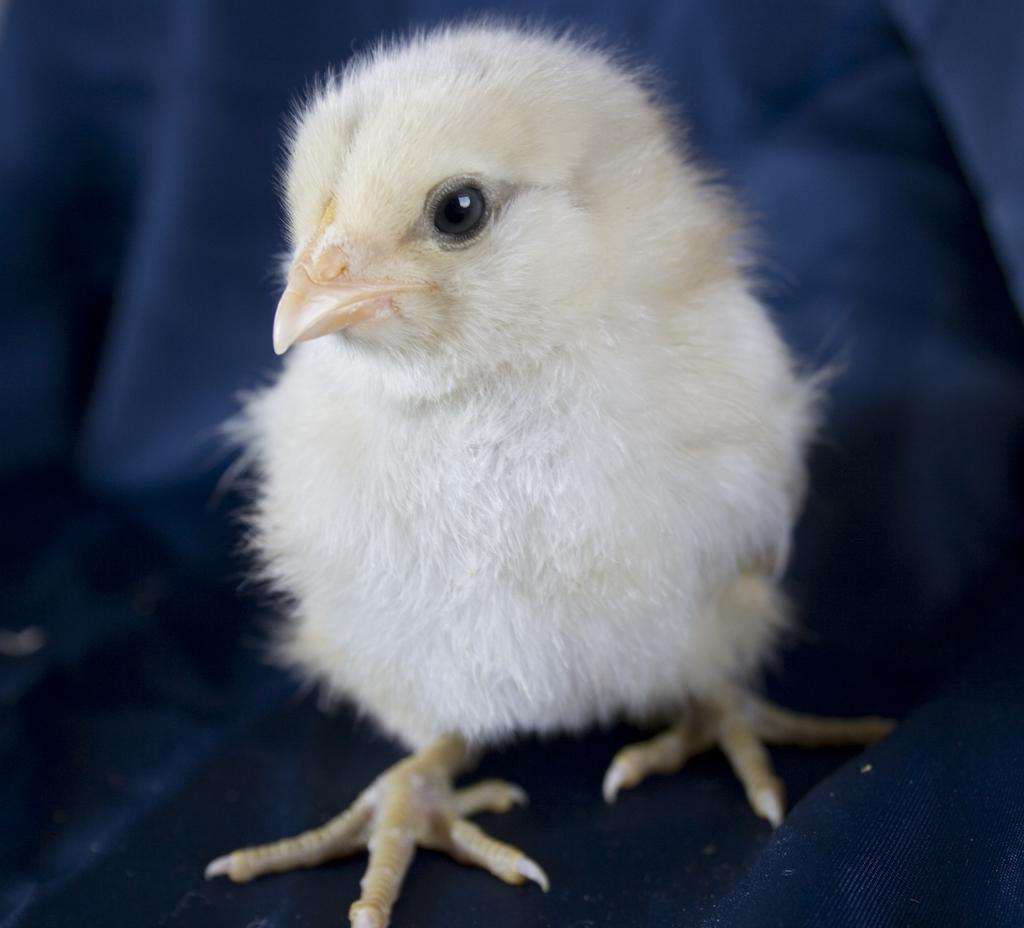What type of animal is in the image? There is a white-colored chick in the image. Where is the chick located in the image? The chick is in the front of the image. What can be seen in the background of the image? There is a cloth visible in the background of the image. What season is depicted in the image? The provided facts do not mention any season, so it cannot be determined from the image. What type of key is being used by the chick in the image? There is no key present in the image; it features a white-colored chick and a cloth in the background. 